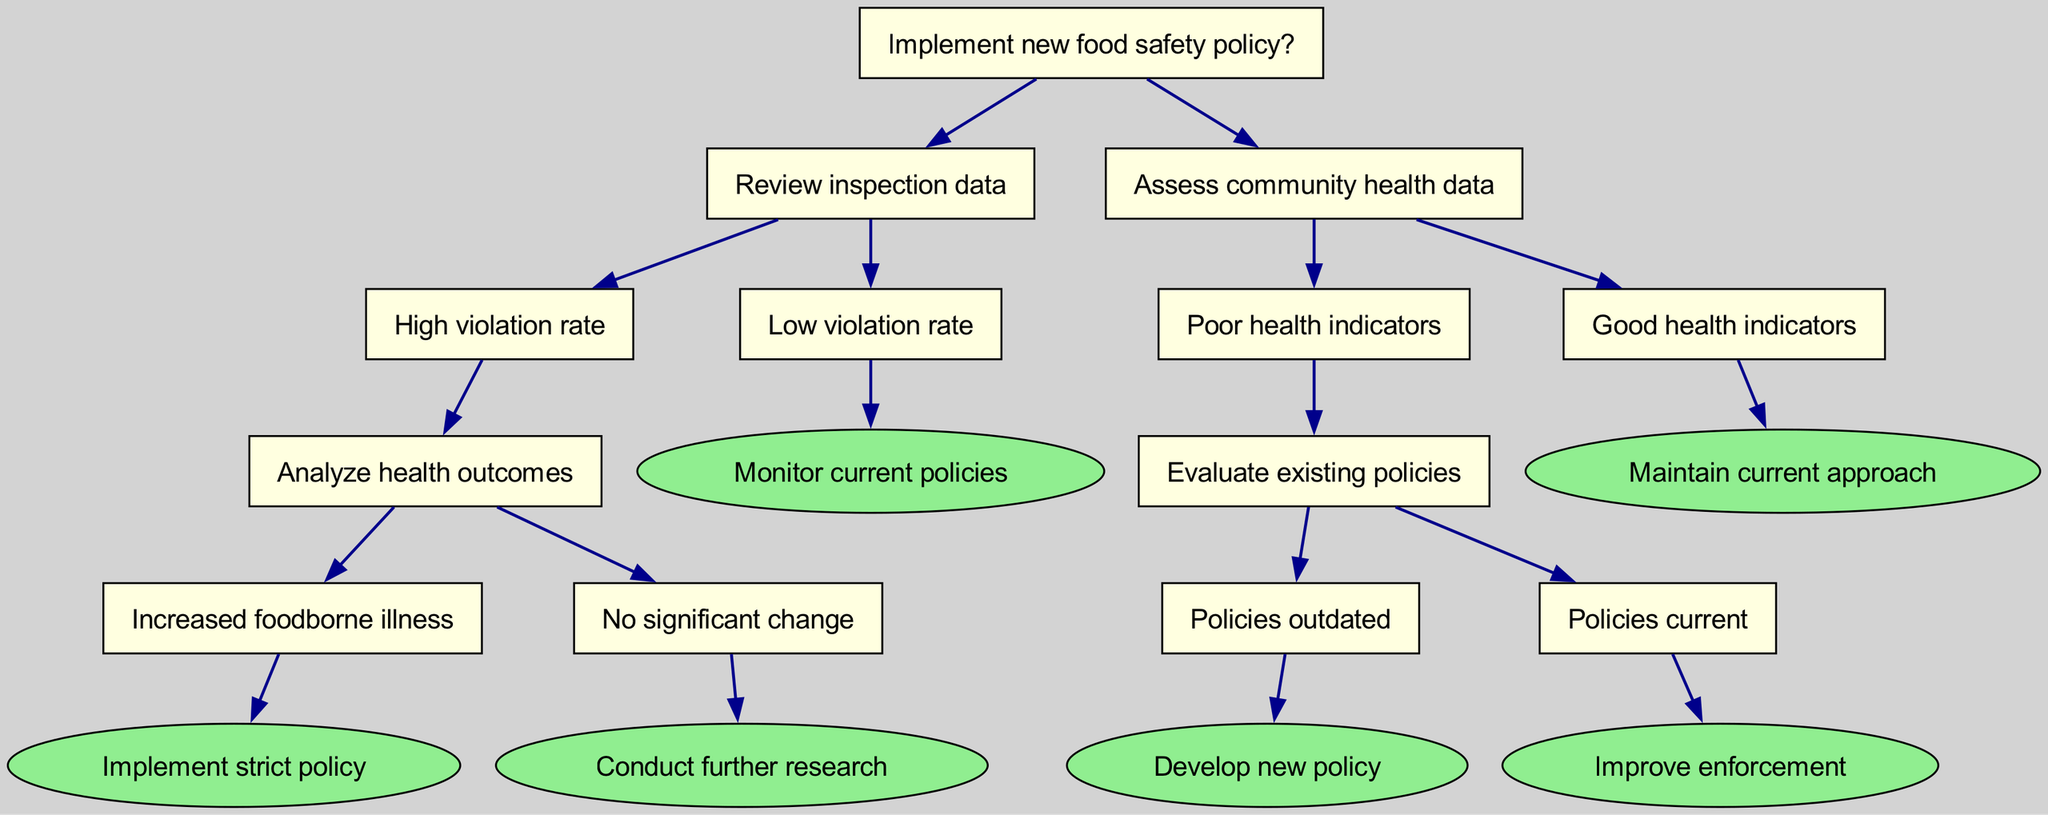What is the root question of this decision tree? The root question directly stated in the diagram is "Implement new food safety policy?". This marks the starting point of the decision-making process outlined in the tree.
Answer: Implement new food safety policy? How many leaf nodes are present in the diagram? When reviewing the diagram, I find that there are four leaf nodes where decisions or outcomes are reached. These are; "Implement strict policy", "Conduct further research", "Develop new policy", and "Improve enforcement".
Answer: 4 What action is taken if there is a low violation rate? According to the diagram, if a low violation rate is observed after reviewing inspection data, the next action is to "Monitor current policies". This indicates that no immediate changes are necessary in such a scenario.
Answer: Monitor current policies Which node leads to the decision to implement a strict policy? Tracing the path in the diagram, the decision to implement a strict policy follows from starting at "Review inspection data" leading to "High violation rate", then to "Analyze health outcomes", and finally to "Increased foodborne illness".
Answer: Increased foodborne illness What is the consequence if health indicators are good? The decision tree specifies that when health indicators are good, the recommended action is to "Maintain current approach". This implies that there is no need to modify existing policies or procedures.
Answer: Maintain current approach If policies are outdated, what is the next step? Following the nodes in the diagram, if policies are identified as outdated after evaluating existing policies, the next step is to "Develop new policy". This indicates that changes are deemed necessary to improve food safety in the community.
Answer: Develop new policy What happens after analyzing health outcomes if there's no significant change in foodborne illness? The diagram states that if there is no significant change in health outcomes following the analysis, the recommended next step is to "Conduct further research". This highlights the need for additional inquiry before making decisions.
Answer: Conduct further research Which node leads to "Improve enforcement"? The decision to "Improve enforcement" comes from a sequence starting from assessing community health data, then evaluating existing policies, and identifying that the policies are current. This indicates that while the policies may be up to date, enforcement may need enhancement.
Answer: Policies current 